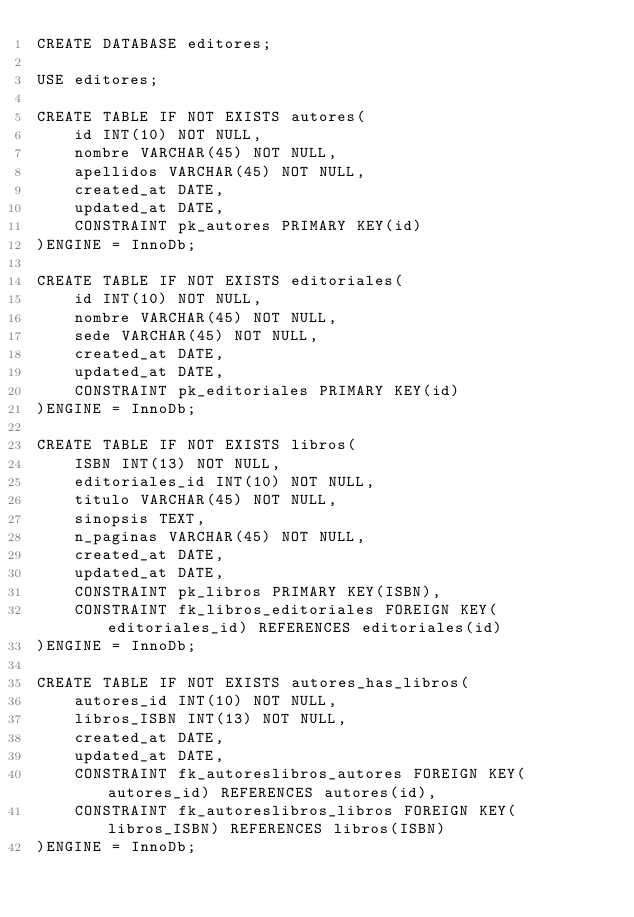Convert code to text. <code><loc_0><loc_0><loc_500><loc_500><_SQL_>CREATE DATABASE editores;

USE editores;

CREATE TABLE IF NOT EXISTS autores(
    id INT(10) NOT NULL,
    nombre VARCHAR(45) NOT NULL,
    apellidos VARCHAR(45) NOT NULL,
    created_at DATE,
    updated_at DATE,
    CONSTRAINT pk_autores PRIMARY KEY(id)
)ENGINE = InnoDb;

CREATE TABLE IF NOT EXISTS editoriales(
    id INT(10) NOT NULL,
    nombre VARCHAR(45) NOT NULL,
    sede VARCHAR(45) NOT NULL,
    created_at DATE,
    updated_at DATE,
    CONSTRAINT pk_editoriales PRIMARY KEY(id)
)ENGINE = InnoDb;

CREATE TABLE IF NOT EXISTS libros(
    ISBN INT(13) NOT NULL,
    editoriales_id INT(10) NOT NULL,
    titulo VARCHAR(45) NOT NULL,
    sinopsis TEXT,
    n_paginas VARCHAR(45) NOT NULL,
    created_at DATE,
    updated_at DATE,
    CONSTRAINT pk_libros PRIMARY KEY(ISBN),
    CONSTRAINT fk_libros_editoriales FOREIGN KEY(editoriales_id) REFERENCES editoriales(id)
)ENGINE = InnoDb;

CREATE TABLE IF NOT EXISTS autores_has_libros(
    autores_id INT(10) NOT NULL,
    libros_ISBN INT(13) NOT NULL,
    created_at DATE,
    updated_at DATE,
    CONSTRAINT fk_autoreslibros_autores FOREIGN KEY(autores_id) REFERENCES autores(id),
    CONSTRAINT fk_autoreslibros_libros FOREIGN KEY(libros_ISBN) REFERENCES libros(ISBN)
)ENGINE = InnoDb;</code> 